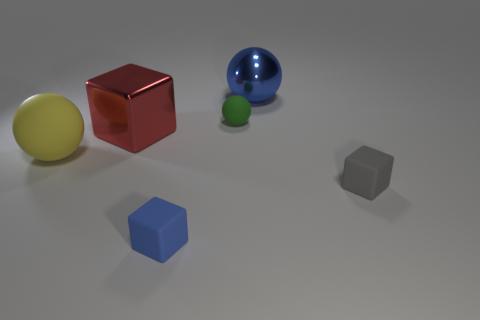What does the arrangement of these objects tell us about the possible theme of the image? The theme of the image suggests an exploration of geometric shapes and how they interact visually. The variation in color and sizes could imply a focus on diversity, contrast, and composition in a controlled environment, alluding to concepts in art or design. Could these objects symbolize anything in a metaphorical sense? Metaphorically, these objects might represent diversity and individuality. Each shape and color stands apart while simultaneously contributing to the balance of the composition. This could symbolize unity in diversity or the idea that various elements can coexist harmoniously within the same space. 